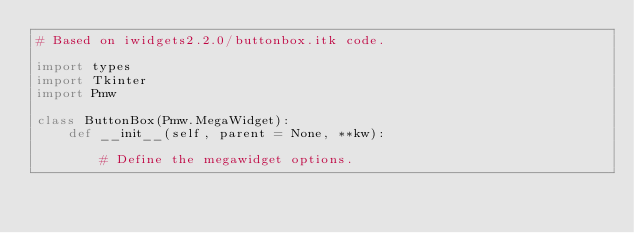<code> <loc_0><loc_0><loc_500><loc_500><_Python_># Based on iwidgets2.2.0/buttonbox.itk code.

import types
import Tkinter
import Pmw

class ButtonBox(Pmw.MegaWidget):
    def __init__(self, parent = None, **kw):

        # Define the megawidget options.</code> 